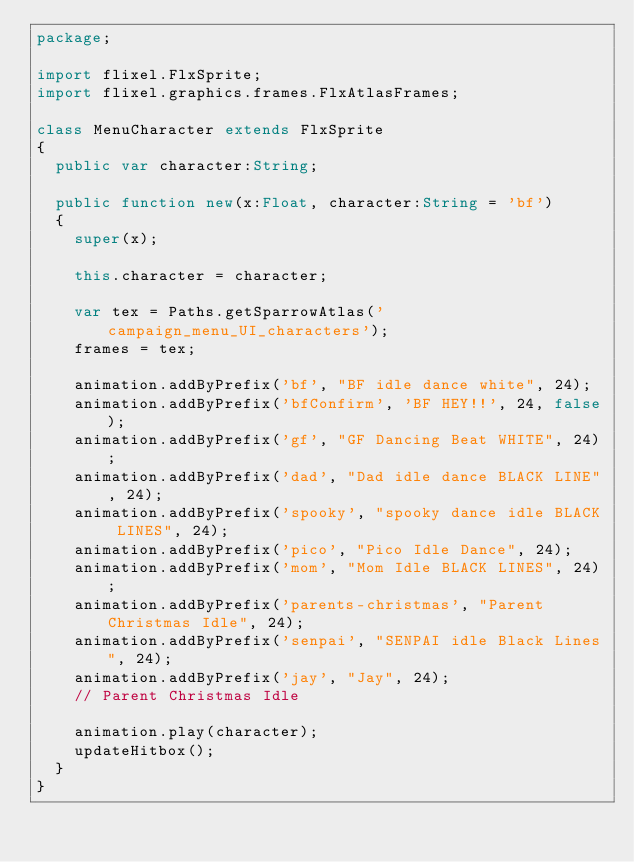<code> <loc_0><loc_0><loc_500><loc_500><_Haxe_>package;

import flixel.FlxSprite;
import flixel.graphics.frames.FlxAtlasFrames;

class MenuCharacter extends FlxSprite
{
	public var character:String;

	public function new(x:Float, character:String = 'bf')
	{
		super(x);

		this.character = character;

		var tex = Paths.getSparrowAtlas('campaign_menu_UI_characters');
		frames = tex;

		animation.addByPrefix('bf', "BF idle dance white", 24);
		animation.addByPrefix('bfConfirm', 'BF HEY!!', 24, false);
		animation.addByPrefix('gf', "GF Dancing Beat WHITE", 24);
		animation.addByPrefix('dad', "Dad idle dance BLACK LINE", 24);
		animation.addByPrefix('spooky', "spooky dance idle BLACK LINES", 24);
		animation.addByPrefix('pico', "Pico Idle Dance", 24);
		animation.addByPrefix('mom', "Mom Idle BLACK LINES", 24);
		animation.addByPrefix('parents-christmas', "Parent Christmas Idle", 24);
		animation.addByPrefix('senpai', "SENPAI idle Black Lines", 24);
		animation.addByPrefix('jay', "Jay", 24);
		// Parent Christmas Idle

		animation.play(character);
		updateHitbox();
	}
}
</code> 